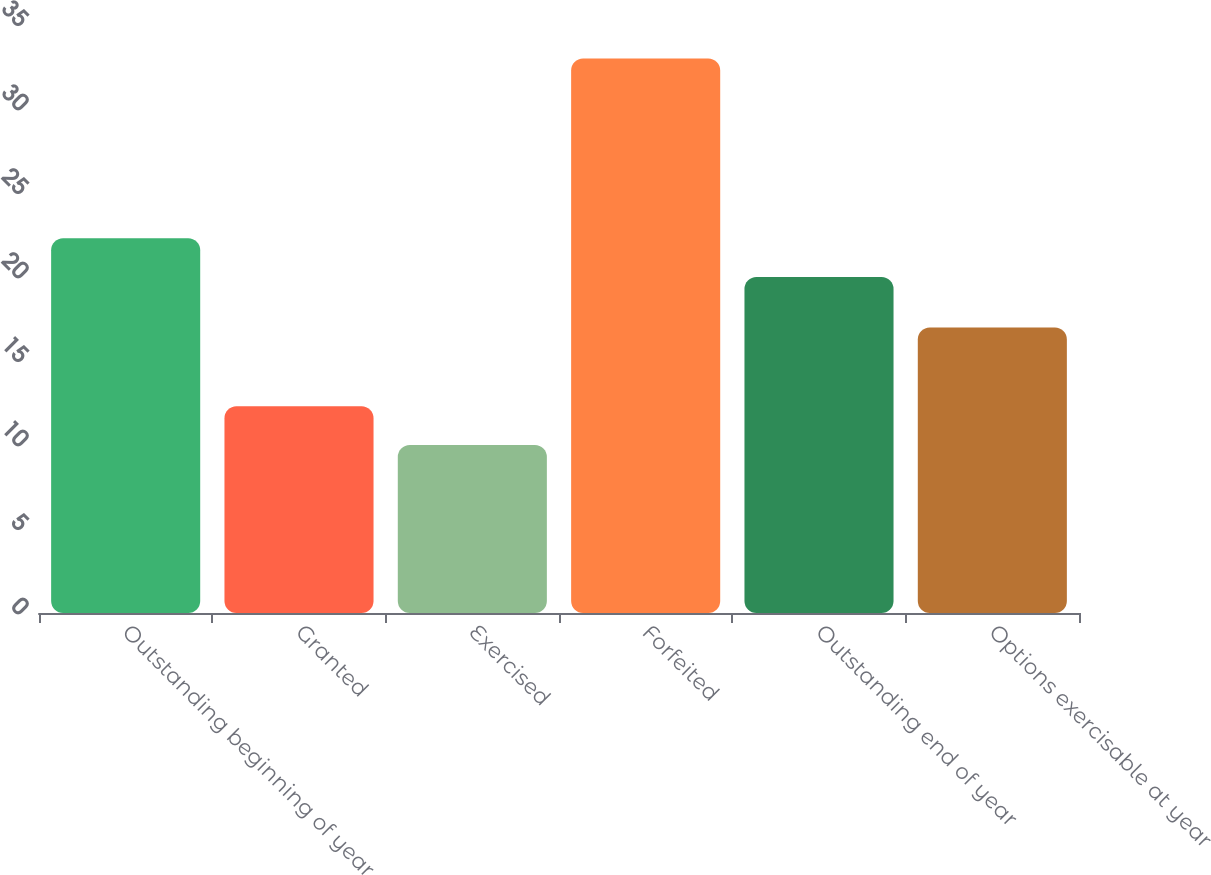<chart> <loc_0><loc_0><loc_500><loc_500><bar_chart><fcel>Outstanding beginning of year<fcel>Granted<fcel>Exercised<fcel>Forfeited<fcel>Outstanding end of year<fcel>Options exercisable at year<nl><fcel>22.3<fcel>12.3<fcel>10<fcel>33<fcel>20<fcel>17<nl></chart> 